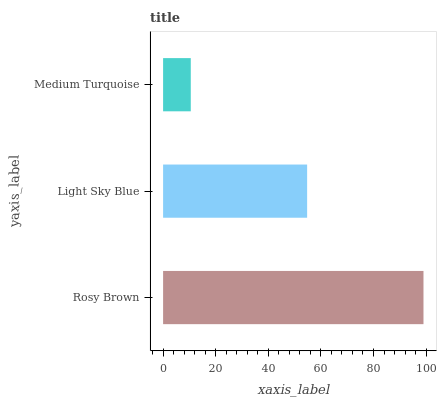Is Medium Turquoise the minimum?
Answer yes or no. Yes. Is Rosy Brown the maximum?
Answer yes or no. Yes. Is Light Sky Blue the minimum?
Answer yes or no. No. Is Light Sky Blue the maximum?
Answer yes or no. No. Is Rosy Brown greater than Light Sky Blue?
Answer yes or no. Yes. Is Light Sky Blue less than Rosy Brown?
Answer yes or no. Yes. Is Light Sky Blue greater than Rosy Brown?
Answer yes or no. No. Is Rosy Brown less than Light Sky Blue?
Answer yes or no. No. Is Light Sky Blue the high median?
Answer yes or no. Yes. Is Light Sky Blue the low median?
Answer yes or no. Yes. Is Medium Turquoise the high median?
Answer yes or no. No. Is Rosy Brown the low median?
Answer yes or no. No. 